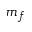<formula> <loc_0><loc_0><loc_500><loc_500>m _ { f }</formula> 